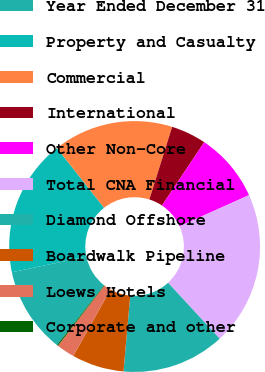<chart> <loc_0><loc_0><loc_500><loc_500><pie_chart><fcel>Year Ended December 31<fcel>Property and Casualty<fcel>Commercial<fcel>International<fcel>Other Non-Core<fcel>Total CNA Financial<fcel>Diamond Offshore<fcel>Boardwalk Pipeline<fcel>Loews Hotels<fcel>Corporate and other<nl><fcel>11.09%<fcel>17.66%<fcel>15.47%<fcel>4.53%<fcel>8.91%<fcel>19.85%<fcel>13.28%<fcel>6.72%<fcel>2.34%<fcel>0.15%<nl></chart> 